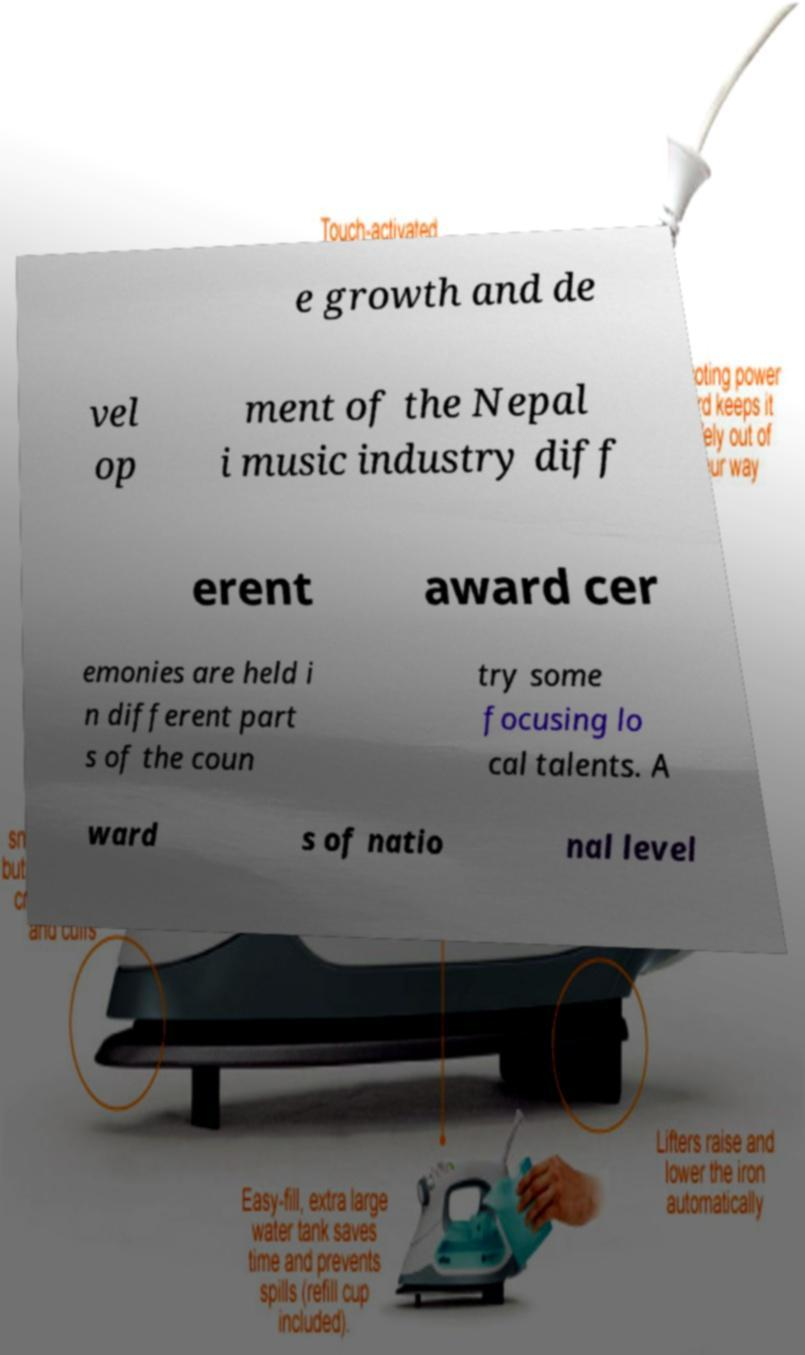I need the written content from this picture converted into text. Can you do that? e growth and de vel op ment of the Nepal i music industry diff erent award cer emonies are held i n different part s of the coun try some focusing lo cal talents. A ward s of natio nal level 